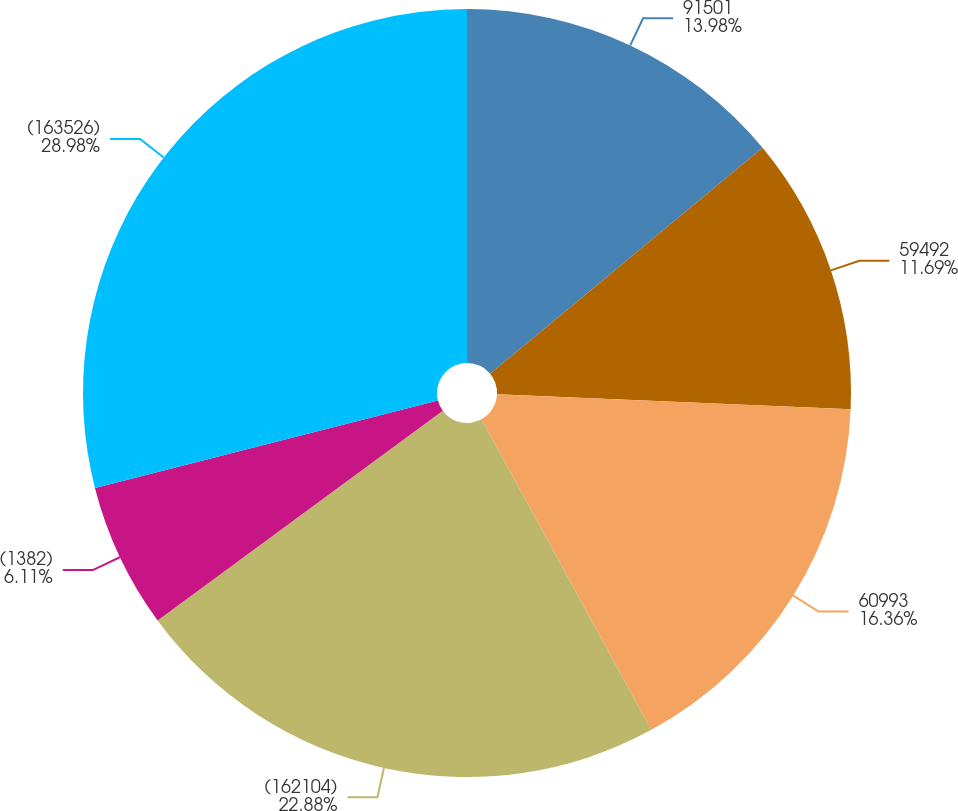Convert chart. <chart><loc_0><loc_0><loc_500><loc_500><pie_chart><fcel>91501<fcel>59492<fcel>60993<fcel>(162104)<fcel>(1382)<fcel>(163526)<nl><fcel>13.98%<fcel>11.69%<fcel>16.36%<fcel>22.88%<fcel>6.11%<fcel>28.98%<nl></chart> 